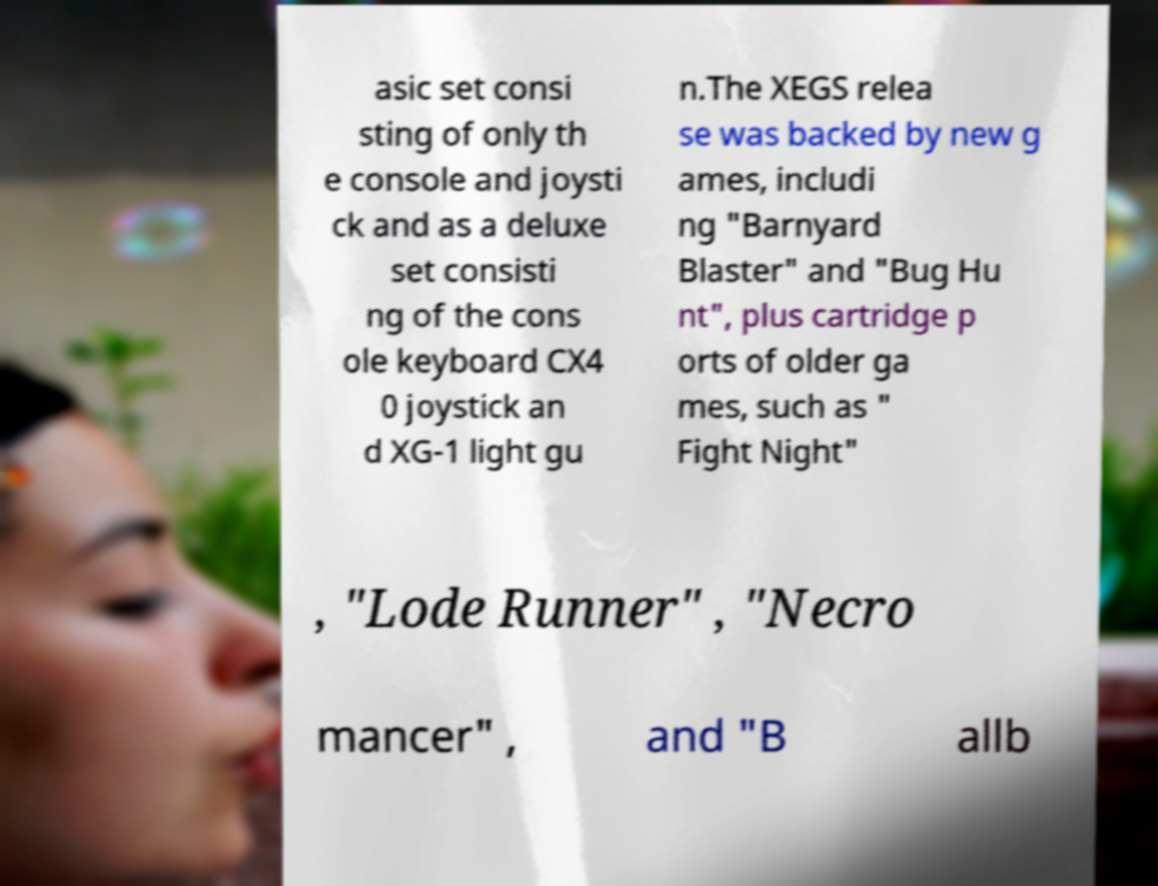Please read and relay the text visible in this image. What does it say? asic set consi sting of only th e console and joysti ck and as a deluxe set consisti ng of the cons ole keyboard CX4 0 joystick an d XG-1 light gu n.The XEGS relea se was backed by new g ames, includi ng "Barnyard Blaster" and "Bug Hu nt", plus cartridge p orts of older ga mes, such as " Fight Night" , "Lode Runner" , "Necro mancer" , and "B allb 